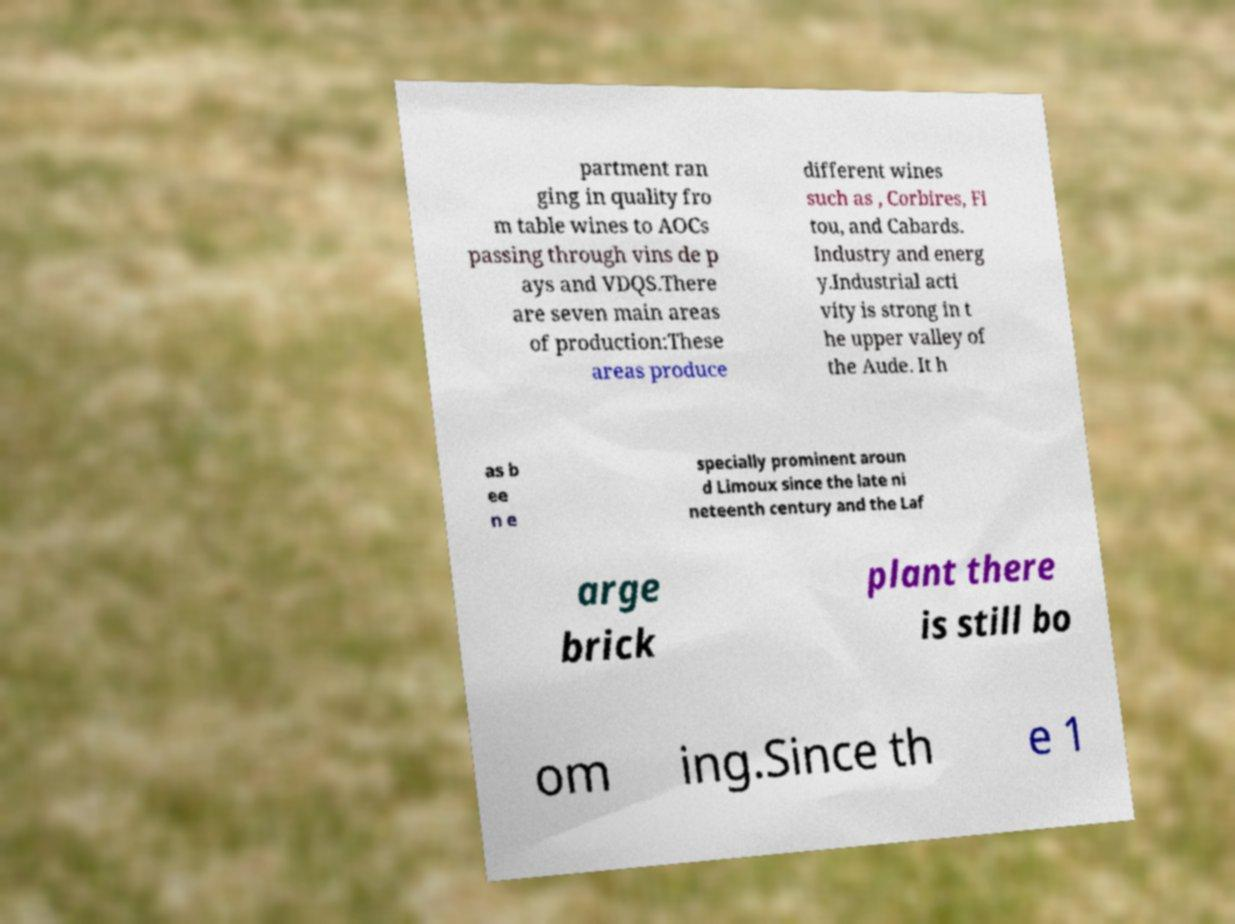Can you accurately transcribe the text from the provided image for me? partment ran ging in quality fro m table wines to AOCs passing through vins de p ays and VDQS.There are seven main areas of production:These areas produce different wines such as , Corbires, Fi tou, and Cabards. Industry and energ y.Industrial acti vity is strong in t he upper valley of the Aude. It h as b ee n e specially prominent aroun d Limoux since the late ni neteenth century and the Laf arge brick plant there is still bo om ing.Since th e 1 